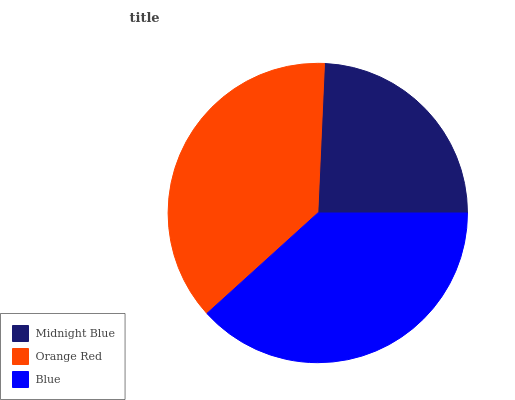Is Midnight Blue the minimum?
Answer yes or no. Yes. Is Blue the maximum?
Answer yes or no. Yes. Is Orange Red the minimum?
Answer yes or no. No. Is Orange Red the maximum?
Answer yes or no. No. Is Orange Red greater than Midnight Blue?
Answer yes or no. Yes. Is Midnight Blue less than Orange Red?
Answer yes or no. Yes. Is Midnight Blue greater than Orange Red?
Answer yes or no. No. Is Orange Red less than Midnight Blue?
Answer yes or no. No. Is Orange Red the high median?
Answer yes or no. Yes. Is Orange Red the low median?
Answer yes or no. Yes. Is Midnight Blue the high median?
Answer yes or no. No. Is Blue the low median?
Answer yes or no. No. 